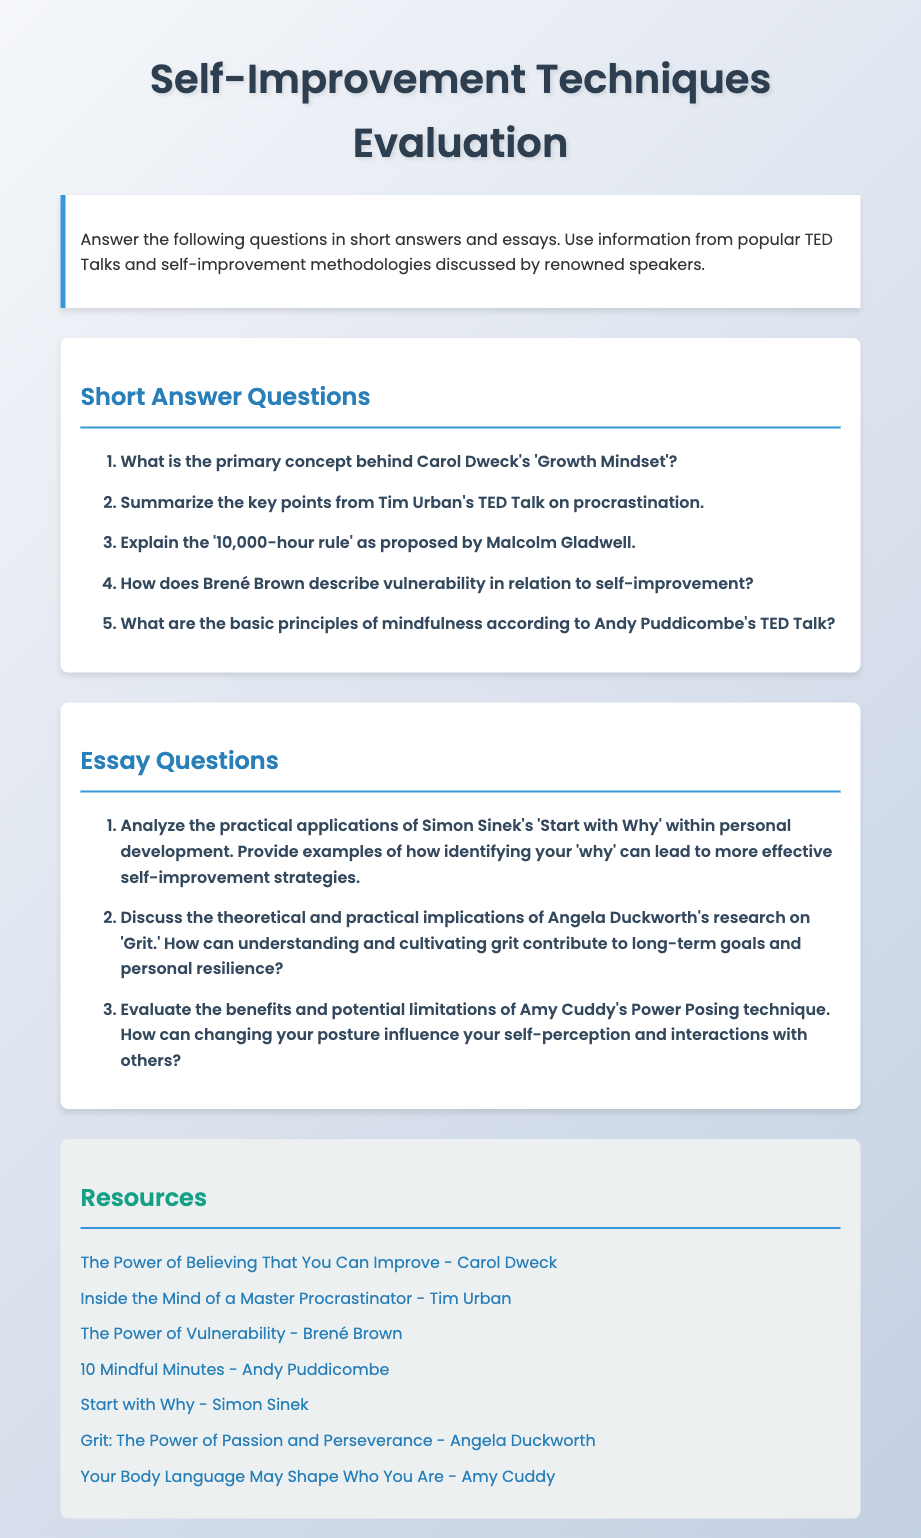What is the title of the exam? The title of the exam is prominently displayed at the top of the document as "Self-Improvement Techniques Evaluation."
Answer: Self-Improvement Techniques Evaluation How many short answer questions are there? The number of short answer questions is indicated in the question section; there are five listed.
Answer: 5 Who is the speaker associated with the '10,000-hour rule'? The speaker noted for discussing the '10,000-hour rule' is Malcolm Gladwell, mentioned in the short answer questions.
Answer: Malcolm Gladwell What is the focus of Brené Brown's TED Talk? The focus of Brené Brown's TED Talk is on vulnerability, as indicated in the question related to her presentation.
Answer: Vulnerability Which speaker's work is related to cultivating 'Grit'? The speaker associated with cultivating 'Grit' is Angela Duckworth, highlighted in the essay questions section.
Answer: Angela Duckworth What does Simon Sinek's talk emphasize in personal development? Simon Sinek's talk emphasizes starting with 'Why' in the context of personal development.
Answer: Start with Why Name one resource listed for the TED Talk on mindfulness. One of the resources provided for mindfulness is a TED Talk by Andy Puddicombe.
Answer: 10 Mindful Minutes What color is used for the headings in the document? The headings in the document are styled with a specific color code, which is a shade of blue, #2980b9.
Answer: Blue What is the pattern of the background in the document? The background of the document features a linear gradient, as specified in the styling of the body.
Answer: Linear gradient 